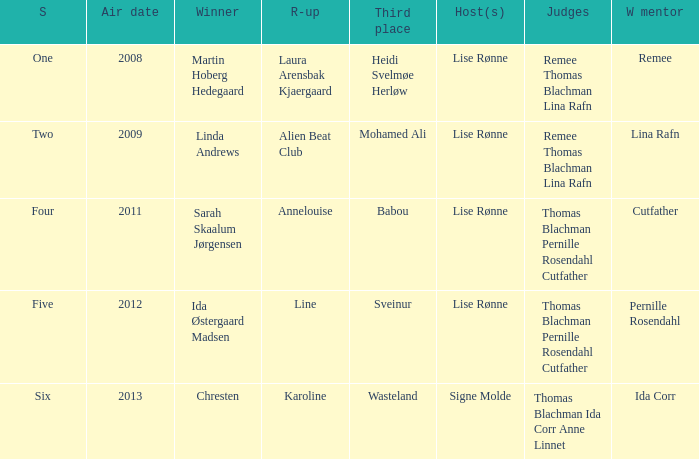Who was the runner-up when Mohamed Ali got third? Alien Beat Club. 